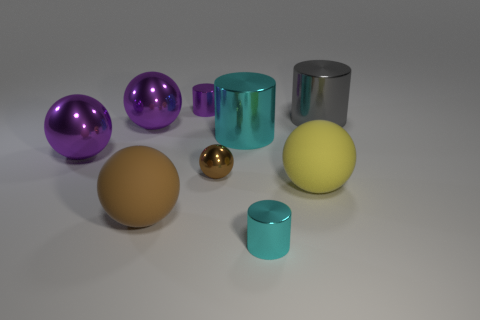Subtract all blue spheres. Subtract all green cylinders. How many spheres are left? 5 Subtract all balls. How many objects are left? 4 Add 1 cylinders. How many cylinders are left? 5 Add 4 gray matte spheres. How many gray matte spheres exist? 4 Subtract 0 gray balls. How many objects are left? 9 Subtract all big balls. Subtract all gray shiny things. How many objects are left? 4 